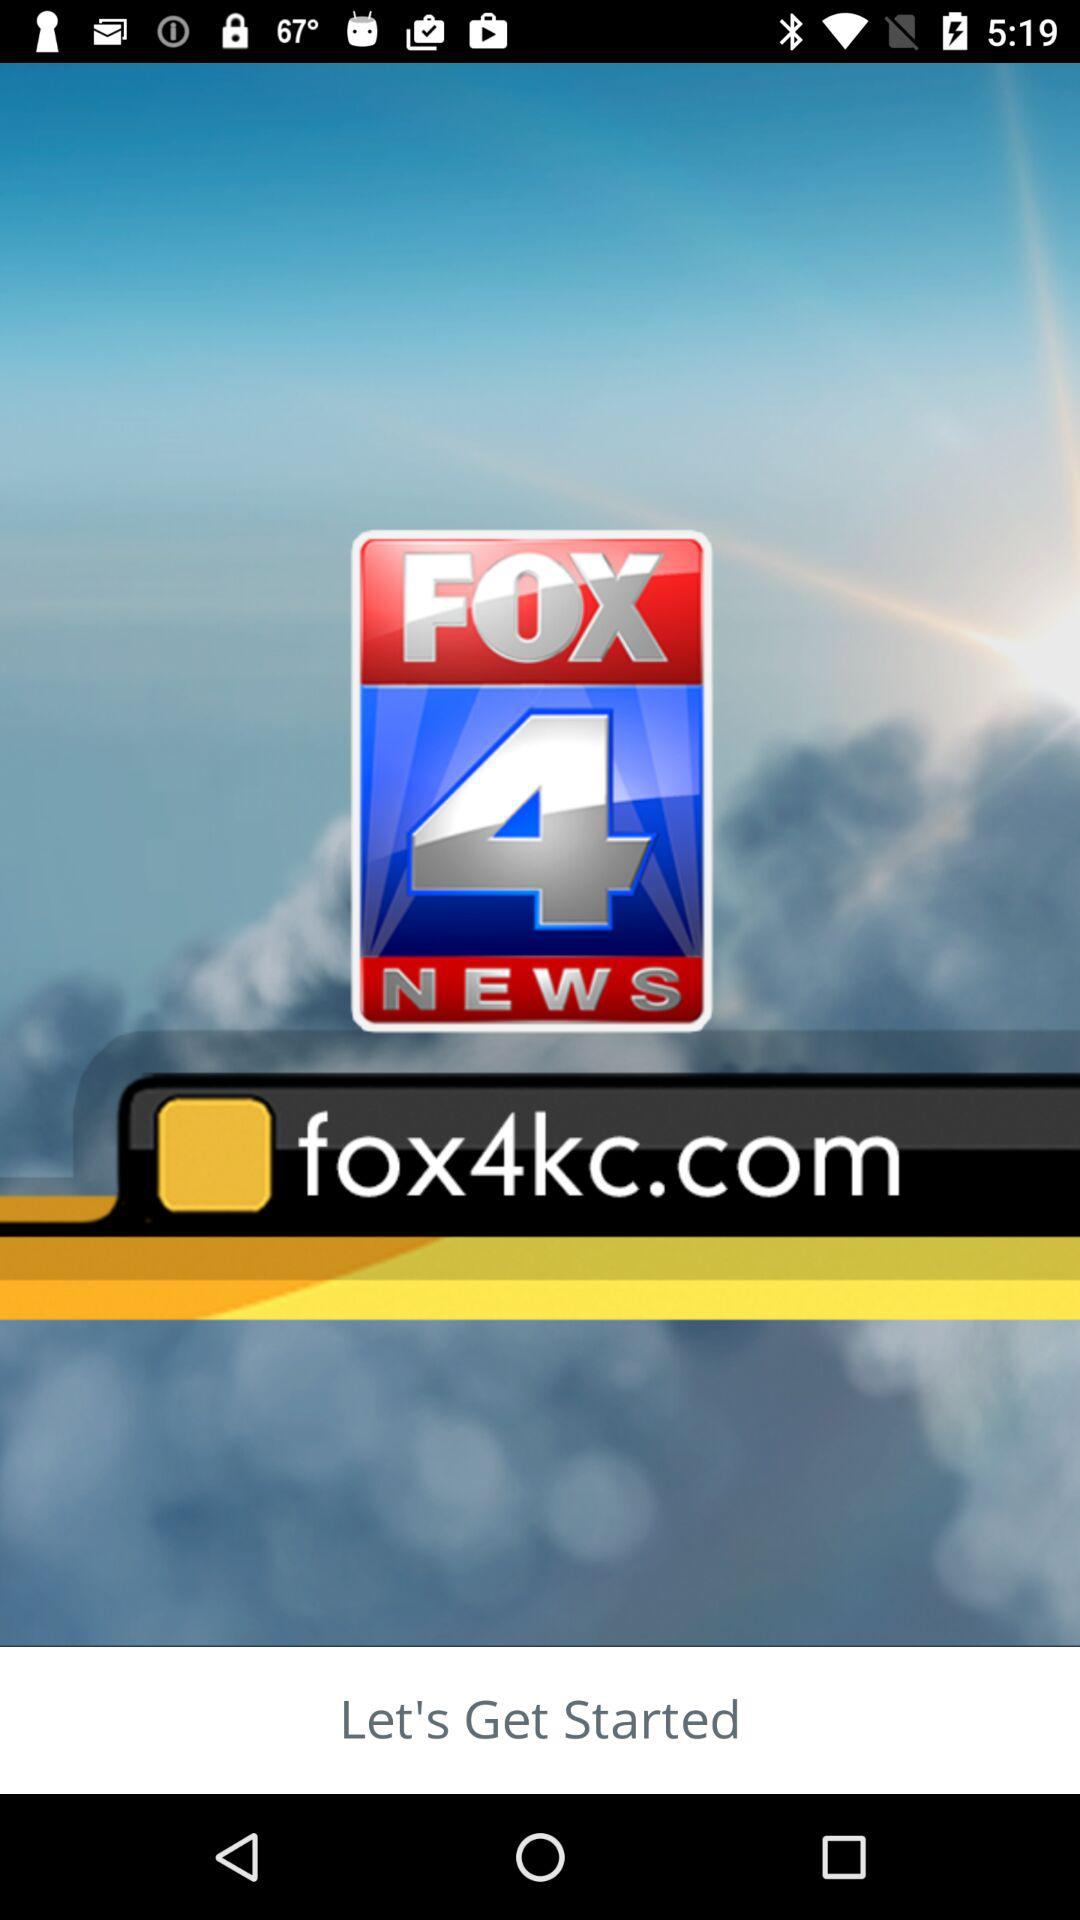What is the name of the application? The name of the application is "FOX 4 NEWS". 